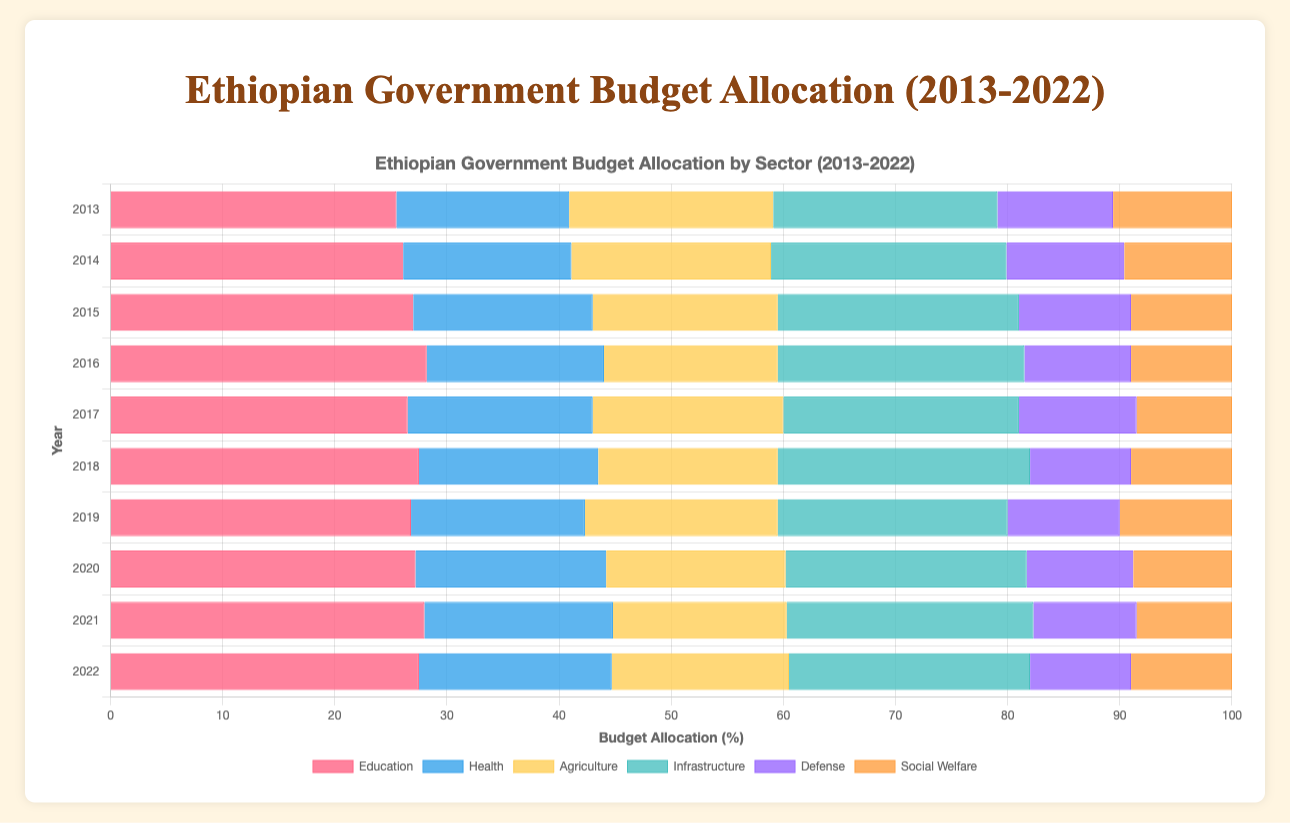What is the average budget allocation for the Education sector over the last decade? Add up the percentage allocations for Education from 2013 to 2022 and then divide by the number of years (10): (25.5 + 26.1 + 27.0 + 28.2 + 26.5 + 27.5 + 26.8 + 27.2 + 28.0 + 27.5) / 10 = 270.3 / 10 = 27.03%
Answer: 27.03% Which year had the highest allocation to Infrastructure? Examine the Infrastructure allocation percentages for each year and identify the maximum: 2013: 20.0, 2014: 21.0, 2015: 21.5, 2016: 22.0, 2017: 21.0, 2018: 22.5, 2019: 20.5, 2020: 21.5, 2021: 22.0, 2022: 21.5. The highest is 22.5% in 2018.
Answer: 2018 Did Defense allocation ever exceed 10% over the observed years? Check each year’s allocation for the Defense sector: 2013: 10.3, 2014: 10.5, 2015: 10.0, 2016: 9.5, 2017: 10.5, 2018: 9.0, 2019: 10.0, 2020: 9.5, 2021: 9.2, 2022: 9.0. Both 2013 and 2014 had allocations exceeding 10%.
Answer: Yes In which year was the smallest budget allocated to Social Welfare? Examine the Social Welfare percentages for each year: 2013: 10.6, 2014: 9.6, 2015: 9.0, 2016: 9.0, 2017: 8.5, 2018: 9.0, 2019: 10.0, 2020: 8.8, 2021: 8.5, 2022: 9.0. The smallest allocation was 8.5% in 2017 and 2021.
Answer: 2017 and 2021 If Education and Health sectors had to be combined into a single sector in 2022, what would be the total percentage of the budget allocated to it? Sum the allocations for Education and Health in 2022: 27.5% (Education) + 17.2% (Health) = 44.7%.
Answer: 44.7% Compare the percentage change in the allocation to Agriculture from 2013 to 2022. Calculate the difference in allocations from 2013 to 2022 for Agriculture: 2013: 18.2%, 2022: 15.8%. Difference: 18.2% - 15.8% = 2.4%. Percentage change: (2.4 / 18.2) x 100% ≈ 13.19% decrease.
Answer: 13.19% decrease How does the 2020 budget allocation for Health compare to the 2017 allocation? Compare the Health allocations for 2020 and 2017: 2020: 17.0%, 2017: 16.5%. The allocation in 2020 was higher by 0.5%.
Answer: 0.5% higher Which sector consistently received the highest allocation every year over the past decade? Look at the highest allocations each year among all sectors: In all years, Education has the highest allocation.
Answer: Education 